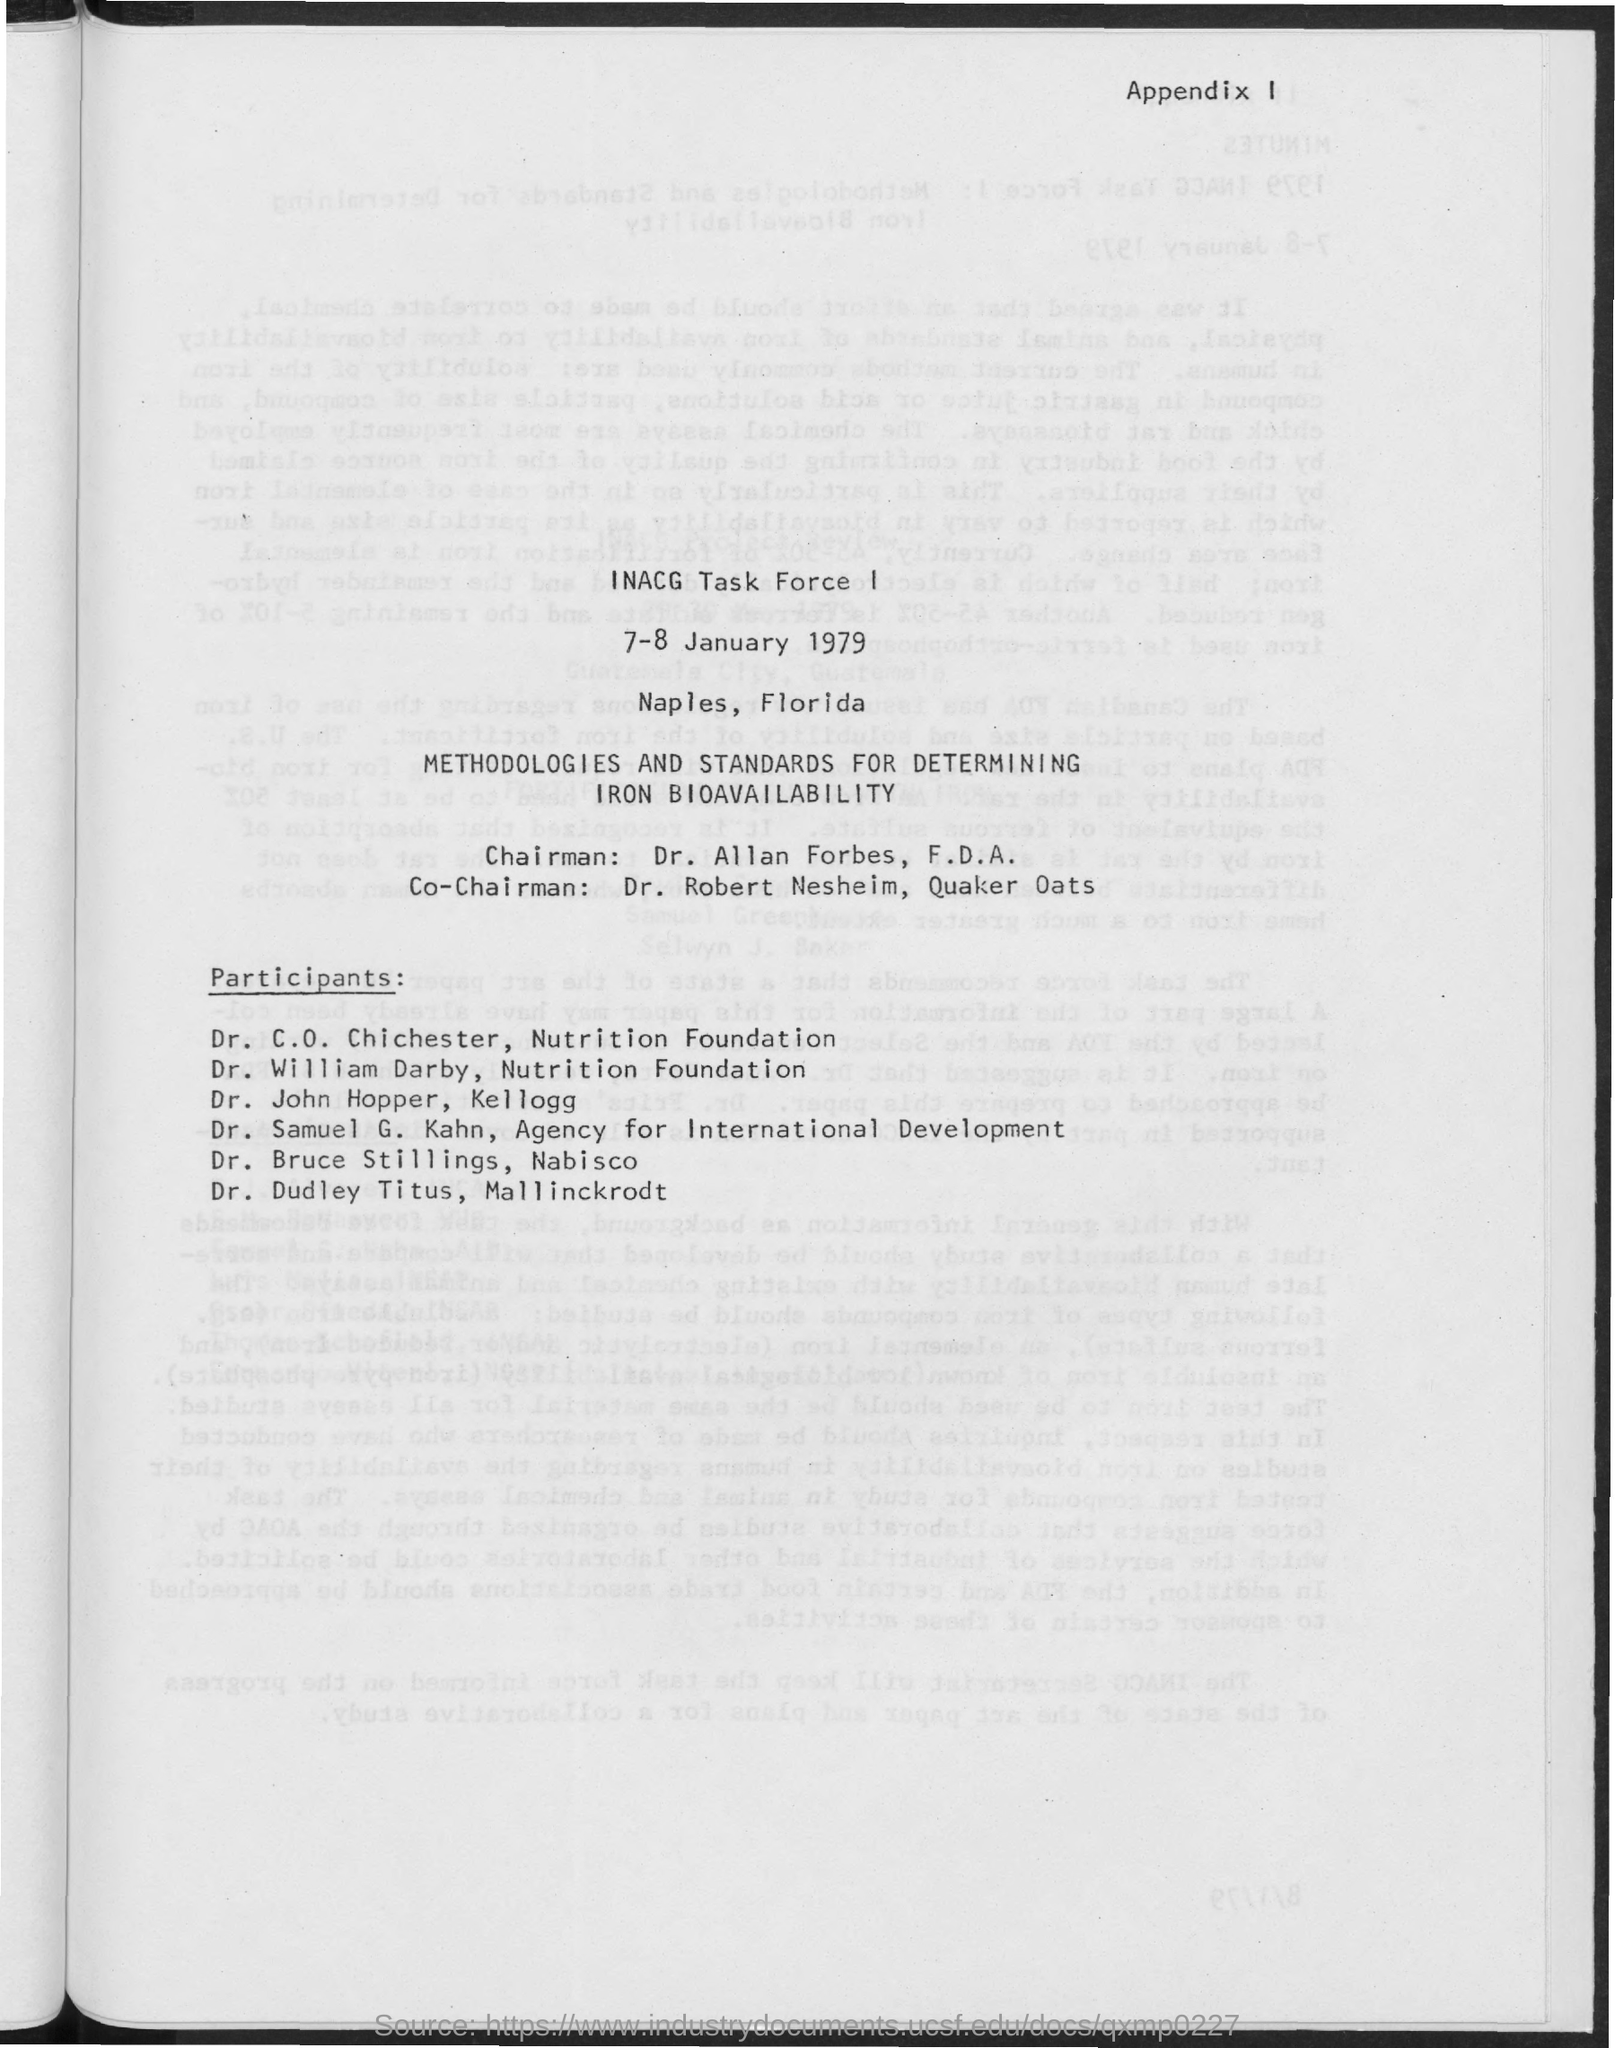What is the name of the chairman mentioned in the document ?
Give a very brief answer. Dr. Allan Forbes. Who is the co-chairman of the quaker oats ?
Offer a very short reply. Dr. Robert Nesheim. 